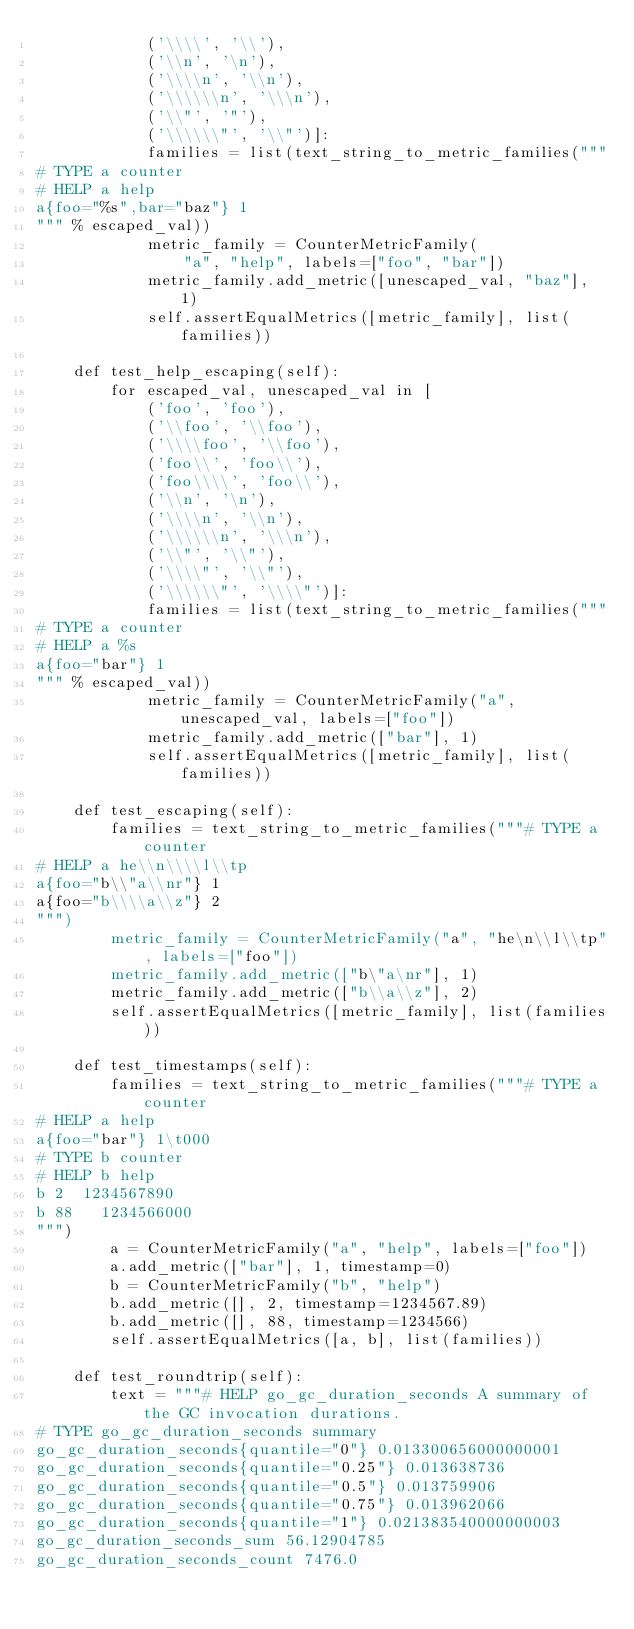Convert code to text. <code><loc_0><loc_0><loc_500><loc_500><_Python_>            ('\\\\', '\\'),
            ('\\n', '\n'),
            ('\\\\n', '\\n'),
            ('\\\\\\n', '\\\n'),
            ('\\"', '"'),
            ('\\\\\\"', '\\"')]:
            families = list(text_string_to_metric_families("""
# TYPE a counter
# HELP a help
a{foo="%s",bar="baz"} 1
""" % escaped_val))
            metric_family = CounterMetricFamily(
                "a", "help", labels=["foo", "bar"])
            metric_family.add_metric([unescaped_val, "baz"], 1)
            self.assertEqualMetrics([metric_family], list(families))

    def test_help_escaping(self):
        for escaped_val, unescaped_val in [
            ('foo', 'foo'),
            ('\\foo', '\\foo'),
            ('\\\\foo', '\\foo'),
            ('foo\\', 'foo\\'),
            ('foo\\\\', 'foo\\'),
            ('\\n', '\n'),
            ('\\\\n', '\\n'),
            ('\\\\\\n', '\\\n'),
            ('\\"', '\\"'),
            ('\\\\"', '\\"'),
            ('\\\\\\"', '\\\\"')]:
            families = list(text_string_to_metric_families("""
# TYPE a counter
# HELP a %s
a{foo="bar"} 1
""" % escaped_val))
            metric_family = CounterMetricFamily("a", unescaped_val, labels=["foo"])
            metric_family.add_metric(["bar"], 1)
            self.assertEqualMetrics([metric_family], list(families))

    def test_escaping(self):
        families = text_string_to_metric_families("""# TYPE a counter
# HELP a he\\n\\\\l\\tp
a{foo="b\\"a\\nr"} 1
a{foo="b\\\\a\\z"} 2
""")
        metric_family = CounterMetricFamily("a", "he\n\\l\\tp", labels=["foo"])
        metric_family.add_metric(["b\"a\nr"], 1)
        metric_family.add_metric(["b\\a\\z"], 2)
        self.assertEqualMetrics([metric_family], list(families))

    def test_timestamps(self):
        families = text_string_to_metric_families("""# TYPE a counter
# HELP a help
a{foo="bar"} 1\t000
# TYPE b counter
# HELP b help
b 2  1234567890
b 88   1234566000   
""")
        a = CounterMetricFamily("a", "help", labels=["foo"])
        a.add_metric(["bar"], 1, timestamp=0)
        b = CounterMetricFamily("b", "help")
        b.add_metric([], 2, timestamp=1234567.89)
        b.add_metric([], 88, timestamp=1234566)
        self.assertEqualMetrics([a, b], list(families))

    def test_roundtrip(self):
        text = """# HELP go_gc_duration_seconds A summary of the GC invocation durations.
# TYPE go_gc_duration_seconds summary
go_gc_duration_seconds{quantile="0"} 0.013300656000000001
go_gc_duration_seconds{quantile="0.25"} 0.013638736
go_gc_duration_seconds{quantile="0.5"} 0.013759906
go_gc_duration_seconds{quantile="0.75"} 0.013962066
go_gc_duration_seconds{quantile="1"} 0.021383540000000003
go_gc_duration_seconds_sum 56.12904785
go_gc_duration_seconds_count 7476.0</code> 